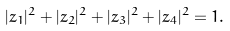<formula> <loc_0><loc_0><loc_500><loc_500>| z _ { 1 } | ^ { 2 } + | z _ { 2 } | ^ { 2 } + | z _ { 3 } | ^ { 2 } + | z _ { 4 } | ^ { 2 } = 1 .</formula> 